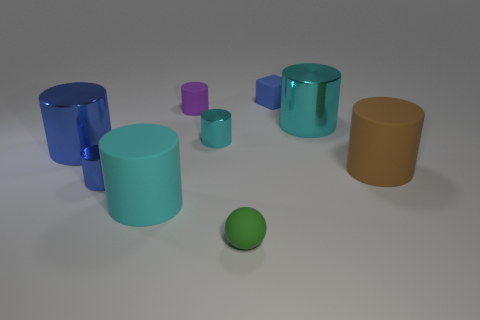What shape are the objects in front? The objects at the front of the image are cylindrical in shape with round tops. Do they all have a reflective surface? Most objects exhibit a reflective surface except for the small cyan block, which has a matte finish. 